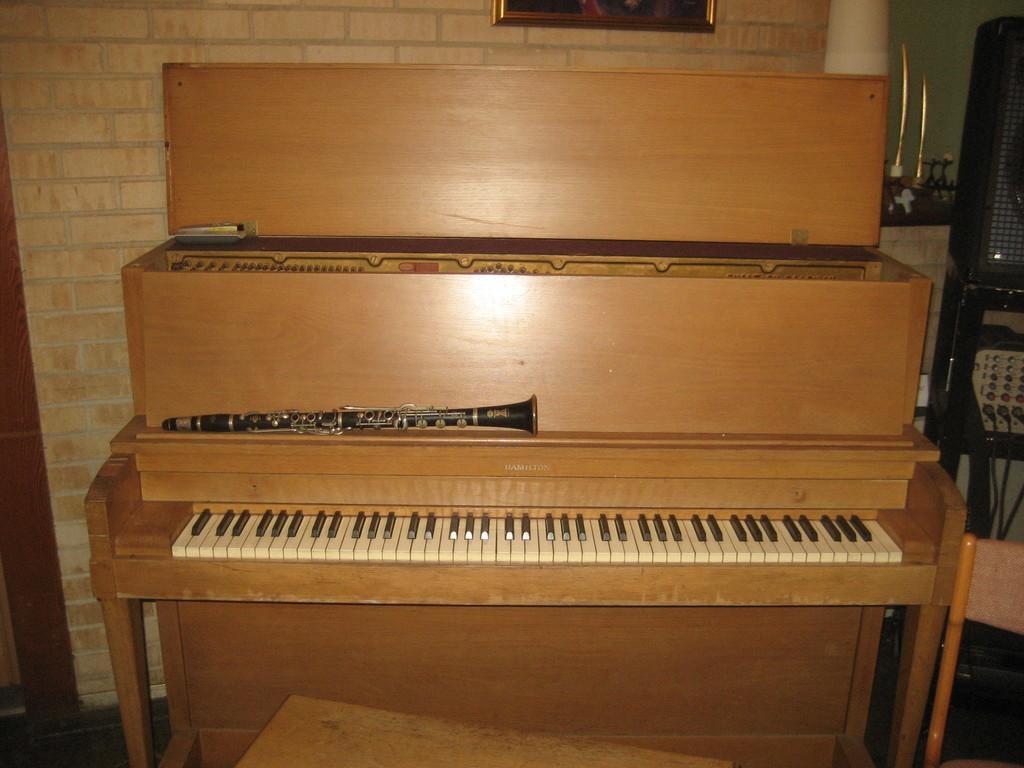In one or two sentences, can you explain what this image depicts? In this picture this brown color piano keyboard is highlighted. On this brown color piano keyboard there is a musical instrument. A picture on wall. This is speaker with stand. 